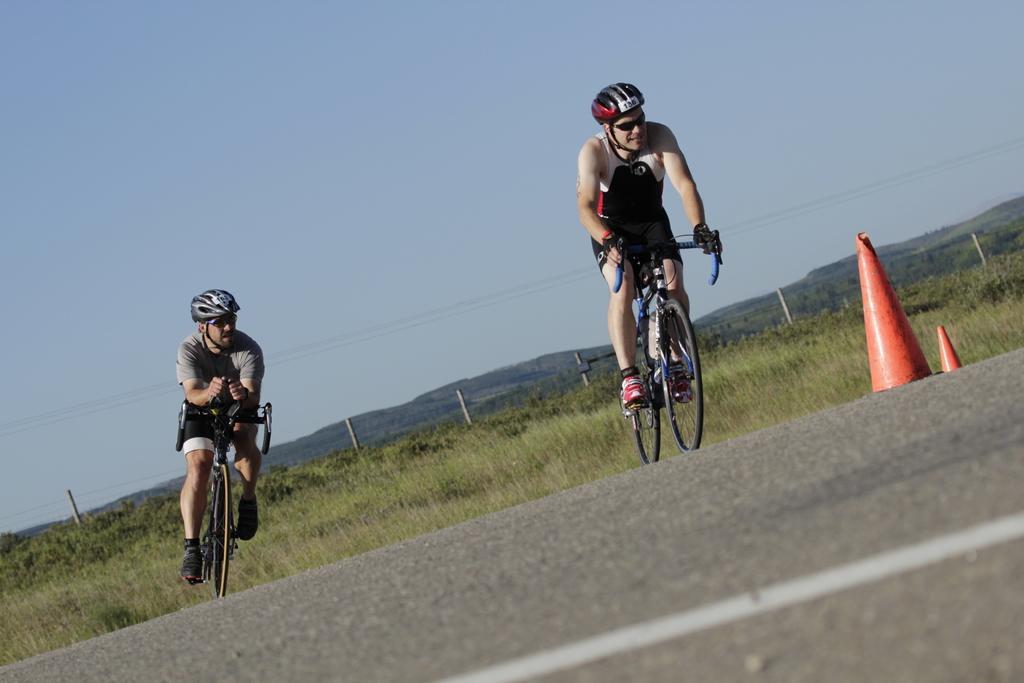Can you describe this image briefly? In this image there are two men riding a bicycle, there are wearing a helmet, there is the road towards the bottom of the image, there are objects on the road, there are plants, there are poles, there are wires, there are mountains, there is the sky towards the top of the image. 